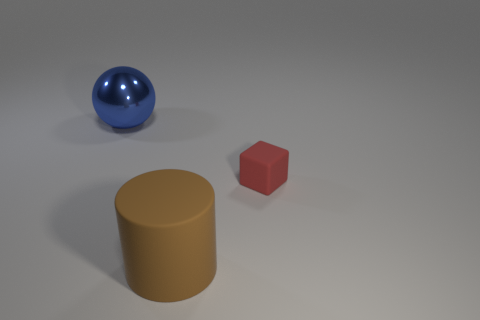There is a big thing on the right side of the large object left of the big brown matte cylinder; is there a red thing to the right of it?
Your answer should be very brief. Yes. What color is the cylinder that is the same size as the metallic ball?
Your answer should be compact. Brown. Is the shape of the large object left of the large brown thing the same as  the red matte thing?
Your response must be concise. No. There is a large thing on the right side of the large object that is on the left side of the rubber thing that is in front of the red rubber thing; what is its color?
Your response must be concise. Brown. Do the big matte thing and the matte object that is to the right of the big brown thing have the same color?
Provide a short and direct response. No. What number of objects are either big balls or small rubber cubes?
Make the answer very short. 2. Is there anything else that is the same color as the small rubber cube?
Ensure brevity in your answer.  No. Do the tiny red thing and the ball left of the brown cylinder have the same material?
Your answer should be compact. No. There is a big object on the right side of the thing that is left of the brown object; what is its shape?
Offer a terse response. Cylinder. What is the shape of the object that is behind the large brown matte object and to the left of the small red matte object?
Keep it short and to the point. Sphere. 